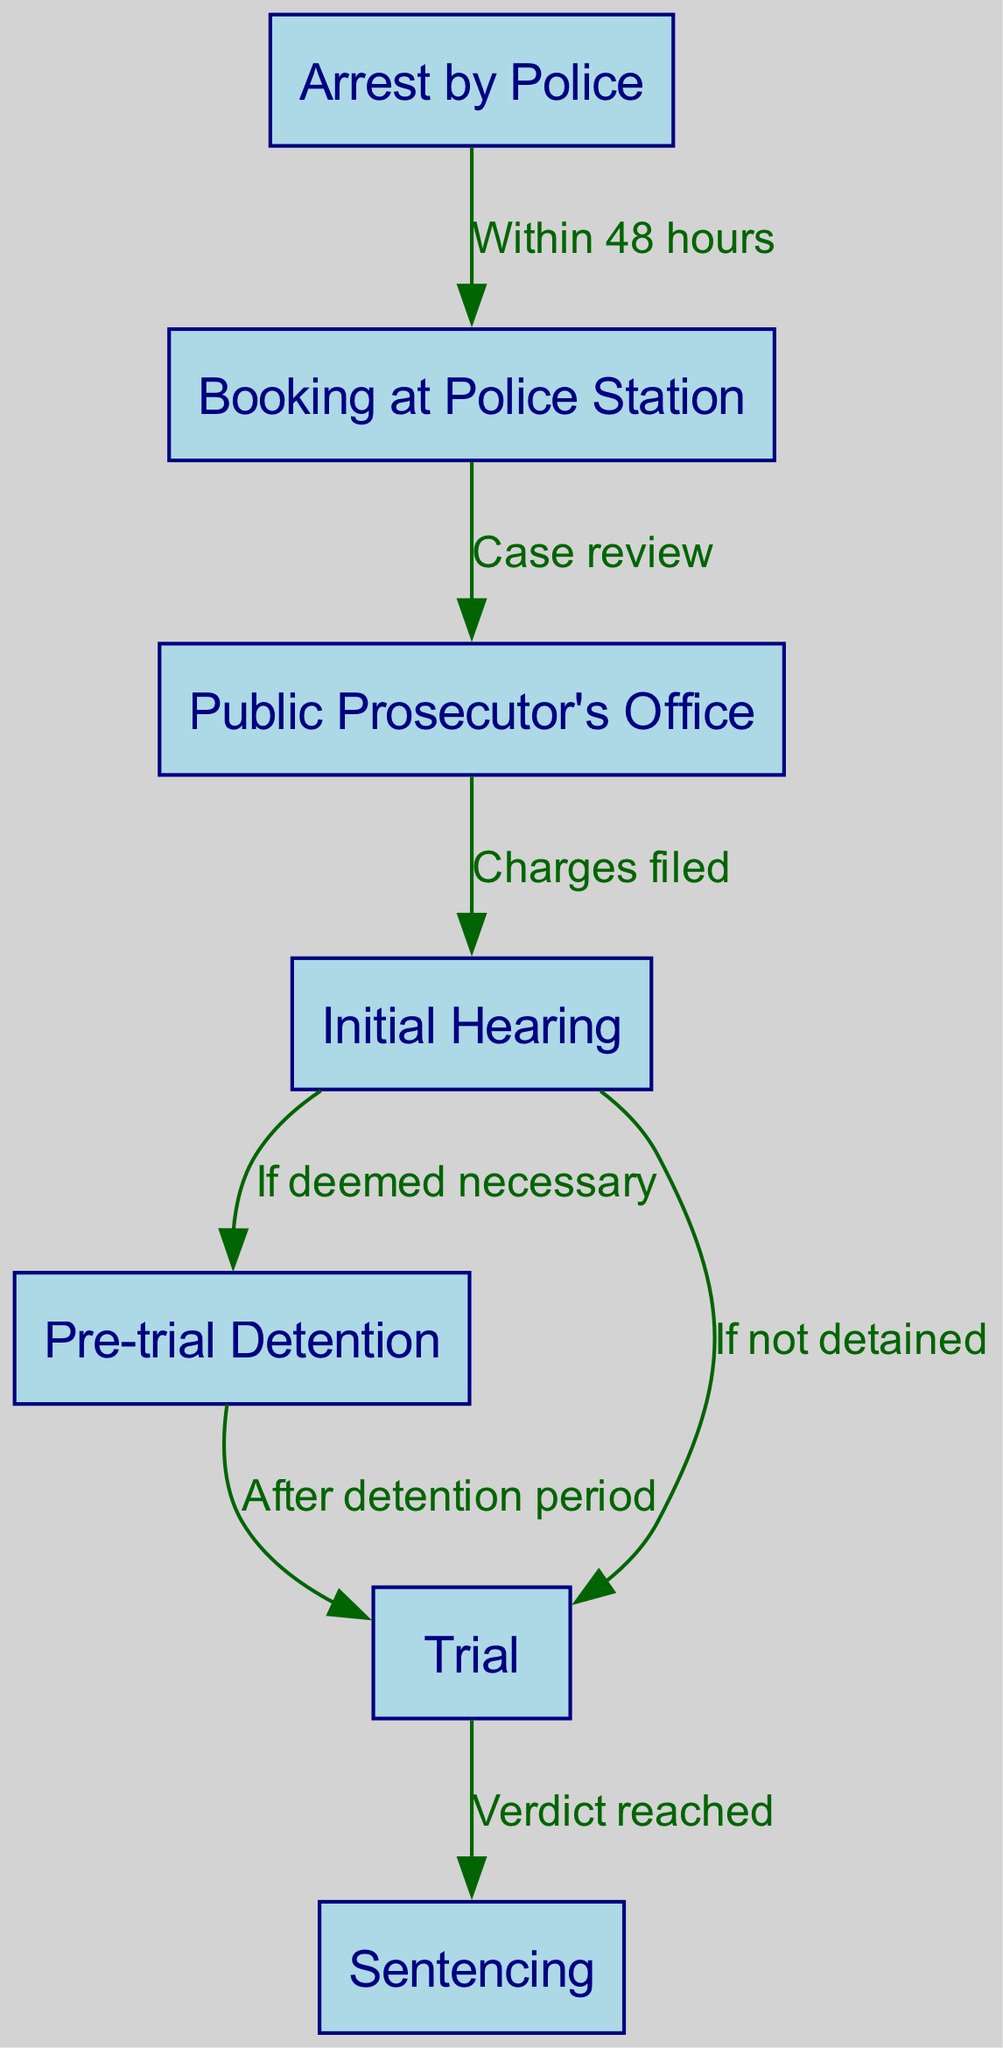What is the first step after arrest? According to the flowchart, the first step after the "Arrest by Police" node is "Booking at Police Station." This is the direct connection following the arrest.
Answer: Booking at Police Station How many nodes are in the diagram? The diagram consists of seven distinct nodes, each representing a stage in the criminal justice process in Mexico, as explicitly listed in the provided data.
Answer: Seven What happens at the initial hearing if deemed necessary? If deemed necessary during the "Initial Hearing," the process moves to "Pre-trial Detention." This is indicated by the relationship labeled "If deemed necessary."
Answer: Pre-trial Detention Which step leads to sentencing? The step leading to "Sentencing" is "Verdict reached," which is the connection coming out of the "Trial" node. This indicates that a decision needs to be made before the final sentencing phase.
Answer: Verdict reached What is the time frame for booking after an arrest? The flowchart specifies that booking occurs "Within 48 hours" after the arrest, as noted in the arrow connecting these two stages.
Answer: Within 48 hours What occurs if the individual is not detained after the initial hearing? If the individual is not detained after the "Initial Hearing," the next step in the process is "Trial." This is indicated in the flowchart with the phrase "If not detained."
Answer: Trial After pre-trial detention, what is the next step? After the "Pre-trial Detention," the process continues to "Trial," as indicated by the edge between these two nodes labeled "After detention period."
Answer: Trial What action follows after filing charges? Following the filing of charges at the "Public Prosecutor's Office," the next step is the "Initial Hearing," as marked in the diagram with the appropriate directed edge.
Answer: Initial Hearing 